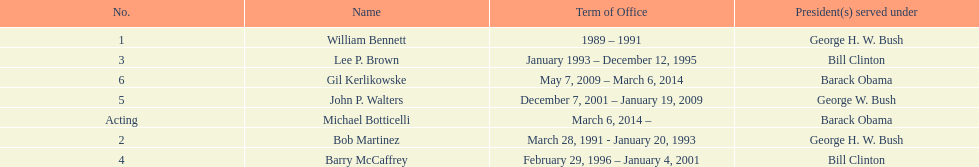How long did the first director serve in office? 2 years. 